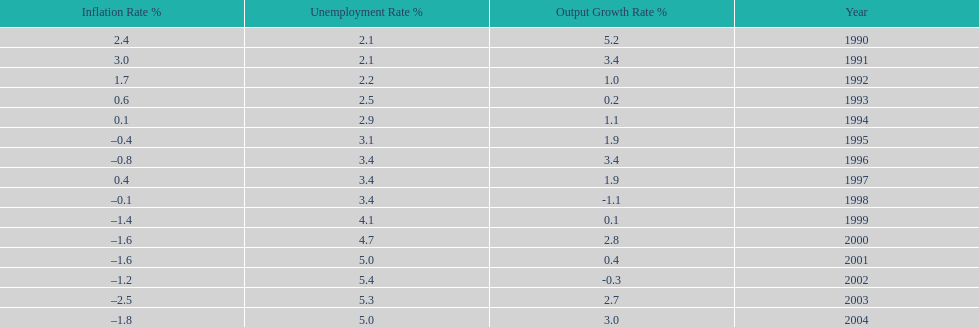When in the 1990's did the inflation rate first become negative? 1995. 